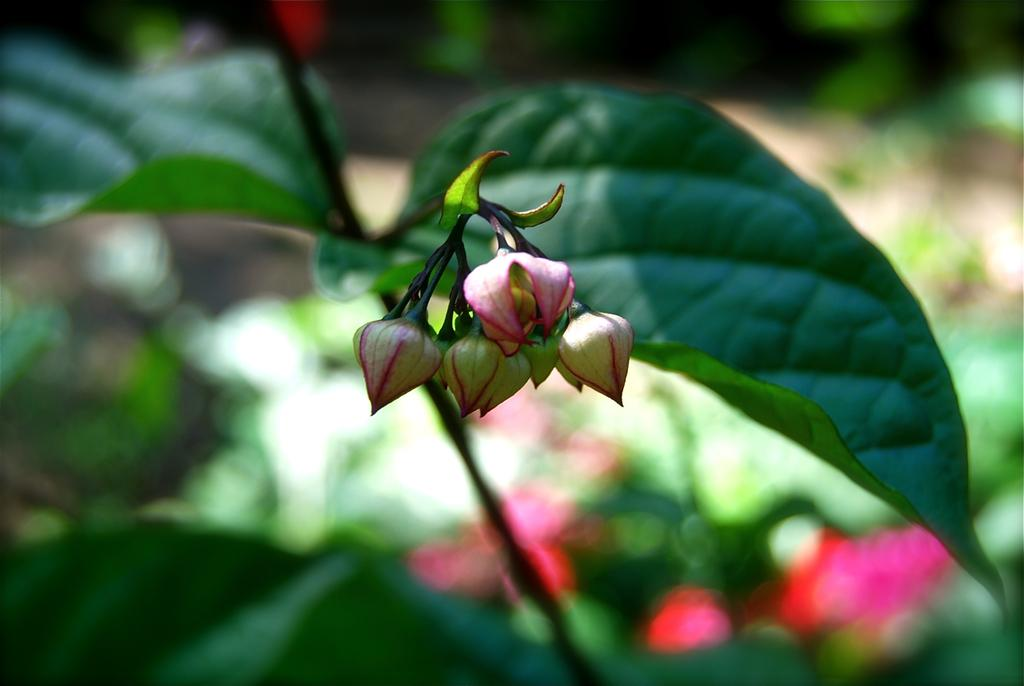What stage of growth are the plants in the image at? There are buds on a plant in the image, indicating that they are in the early stages of growth. What type of memory is stored in the buds of the plant in the image? There is no indication of memory storage in the buds of the plant in the image; they are simply a part of the plant's growth process. 